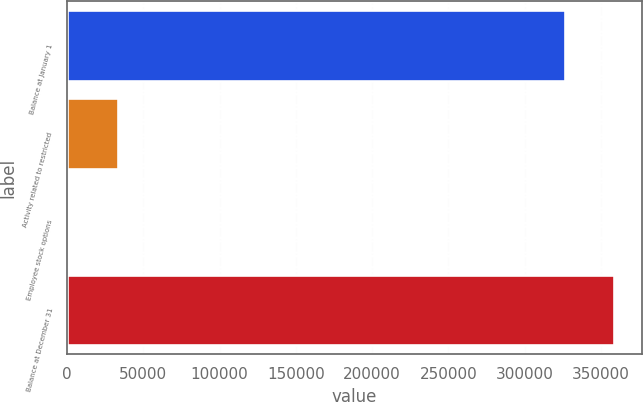<chart> <loc_0><loc_0><loc_500><loc_500><bar_chart><fcel>Balance at January 1<fcel>Activity related to restricted<fcel>Employee stock options<fcel>Balance at December 31<nl><fcel>326133<fcel>33097.3<fcel>416<fcel>358814<nl></chart> 